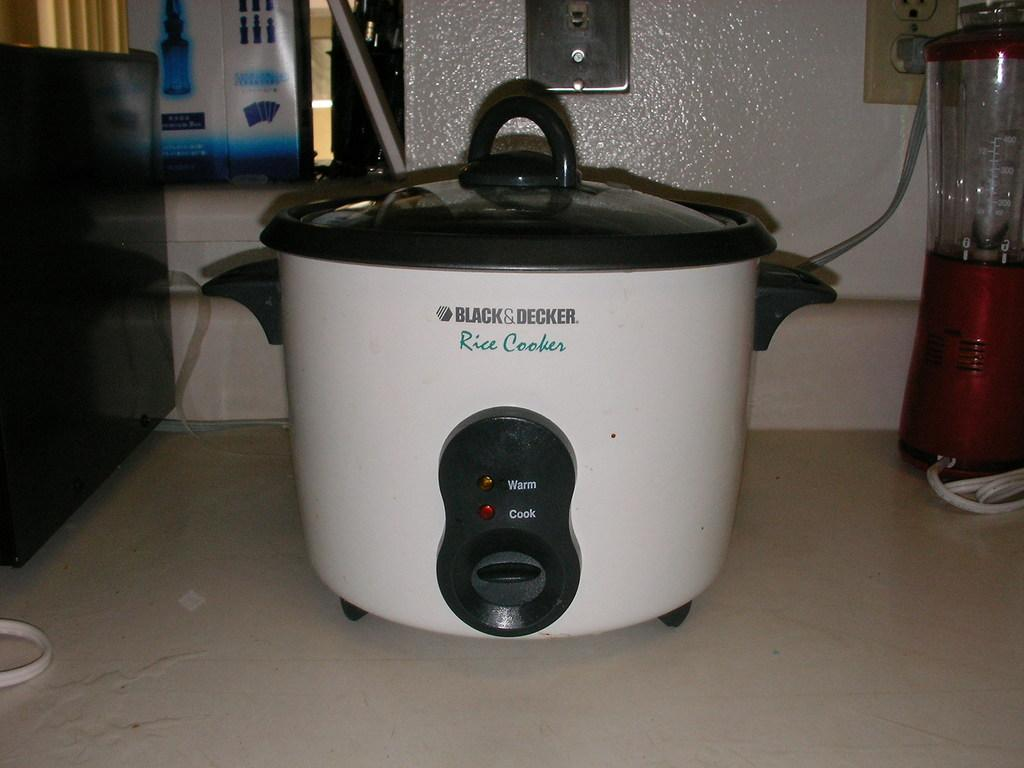<image>
Describe the image concisely. White rice cooker made by Black&Decker on top of a kitchen top. 